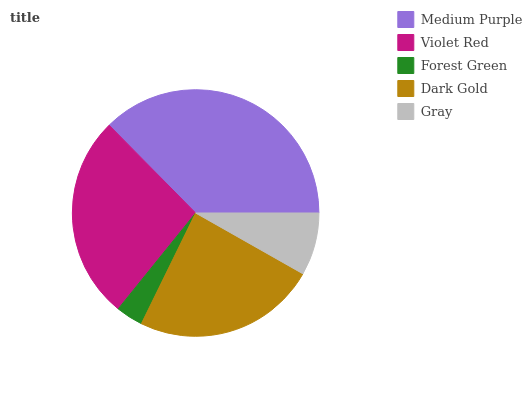Is Forest Green the minimum?
Answer yes or no. Yes. Is Medium Purple the maximum?
Answer yes or no. Yes. Is Violet Red the minimum?
Answer yes or no. No. Is Violet Red the maximum?
Answer yes or no. No. Is Medium Purple greater than Violet Red?
Answer yes or no. Yes. Is Violet Red less than Medium Purple?
Answer yes or no. Yes. Is Violet Red greater than Medium Purple?
Answer yes or no. No. Is Medium Purple less than Violet Red?
Answer yes or no. No. Is Dark Gold the high median?
Answer yes or no. Yes. Is Dark Gold the low median?
Answer yes or no. Yes. Is Gray the high median?
Answer yes or no. No. Is Violet Red the low median?
Answer yes or no. No. 